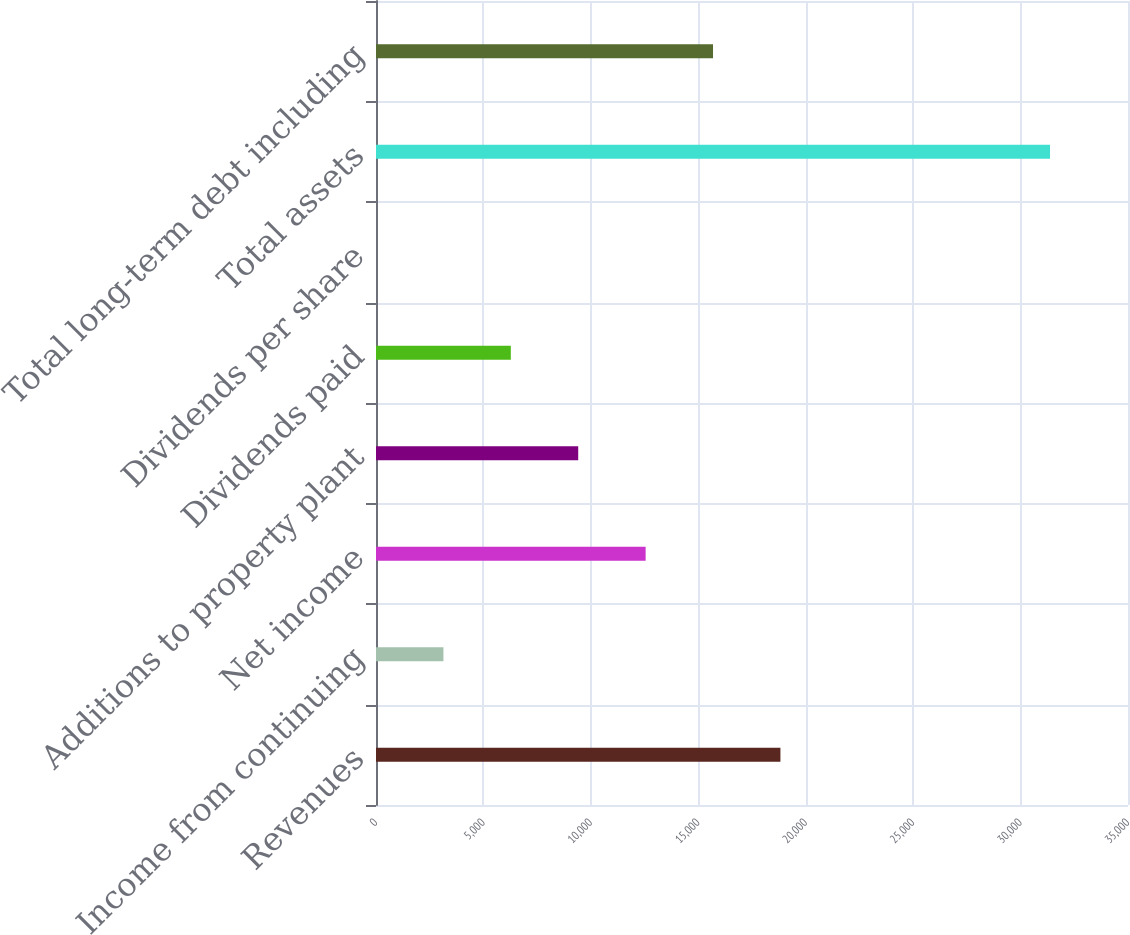Convert chart. <chart><loc_0><loc_0><loc_500><loc_500><bar_chart><fcel>Revenues<fcel>Income from continuing<fcel>Net income<fcel>Additions to property plant<fcel>Dividends paid<fcel>Dividends per share<fcel>Total assets<fcel>Total long-term debt including<nl><fcel>18822.9<fcel>3137.82<fcel>12548.9<fcel>9411.86<fcel>6274.84<fcel>0.8<fcel>31371<fcel>15685.9<nl></chart> 